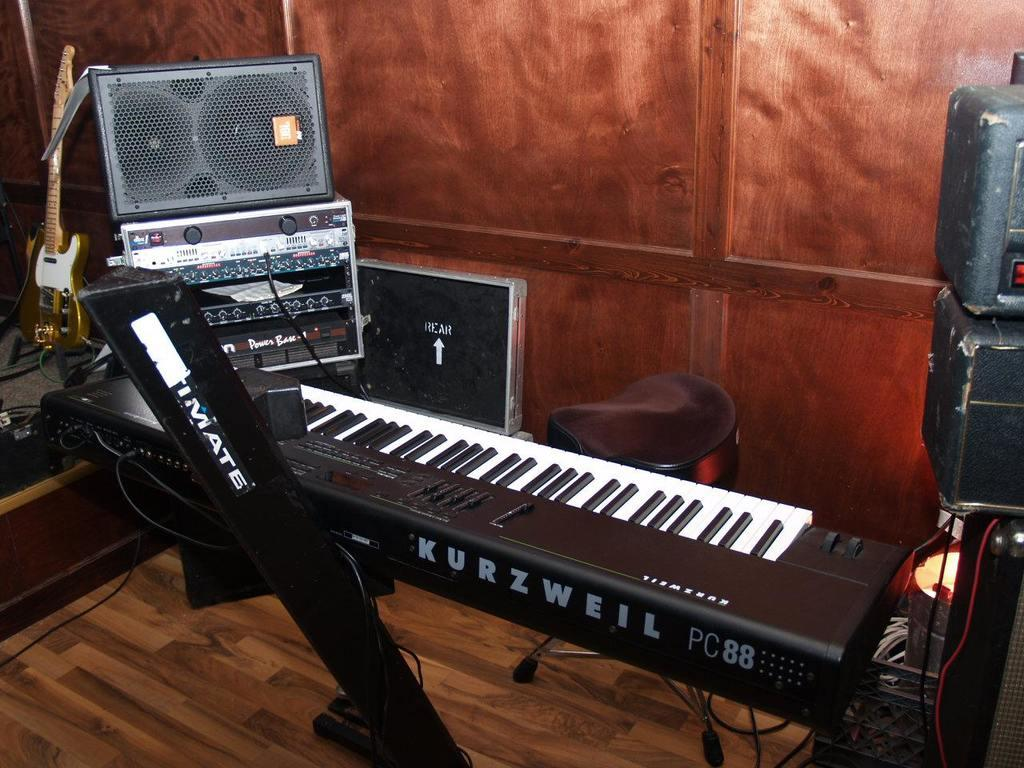What musical instruments are visible in the image? There is a keyboard and a guitar in the image. What equipment might be used for amplifying sound in the image? There are speakers in the image. How many chairs are in the room? There is one chair in the room. What is the wall behind the instruments made of? The wall behind the instruments is made of wood. What type of berry is being used as a decoration on the keyboard in the image? There are no berries present in the image, and the keyboard is not being used as a decorative item. 